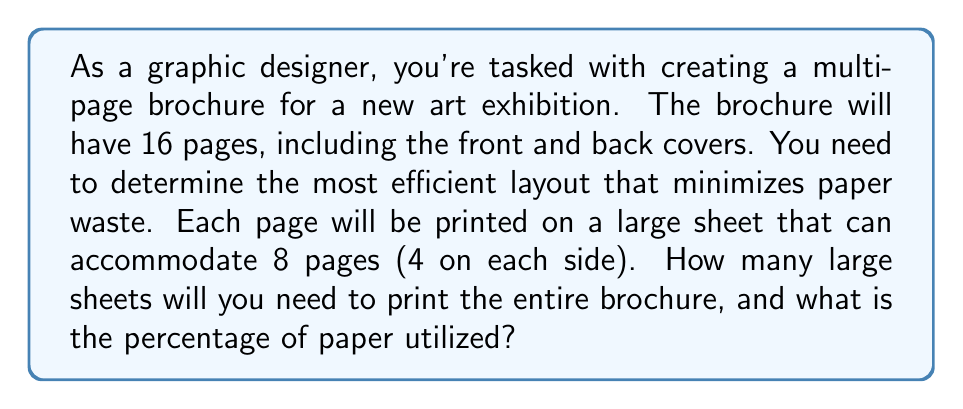Give your solution to this math problem. Let's approach this step-by-step:

1. First, we need to calculate the total number of pages required:
   Total pages = 16

2. Each large sheet can accommodate 8 pages (4 on each side):
   Pages per sheet = 8

3. To calculate the number of sheets needed, we divide the total pages by pages per sheet:
   $$\text{Sheets needed} = \frac{\text{Total pages}}{\text{Pages per sheet}} = \frac{16}{8} = 2$$

4. Now, let's calculate the paper utilization:
   - Total available page spaces = Sheets needed × Pages per sheet
   $$\text{Total available page spaces} = 2 \times 8 = 16$$

5. Calculate the utilization percentage:
   $$\text{Utilization percentage} = \frac{\text{Pages used}}{\text{Total available page spaces}} \times 100\%$$
   $$= \frac{16}{16} \times 100\% = 100\%$$

This layout results in 100% paper utilization, which is the most efficient possible layout for this brochure design.
Answer: You will need 2 large sheets to print the entire 16-page brochure, with 100% paper utilization. 